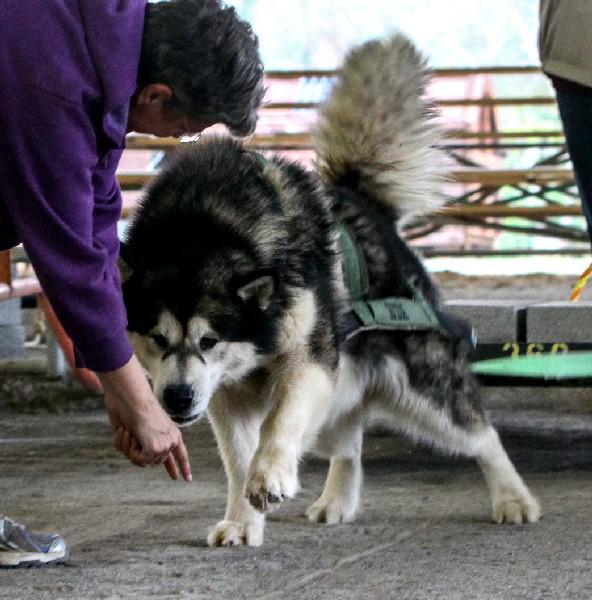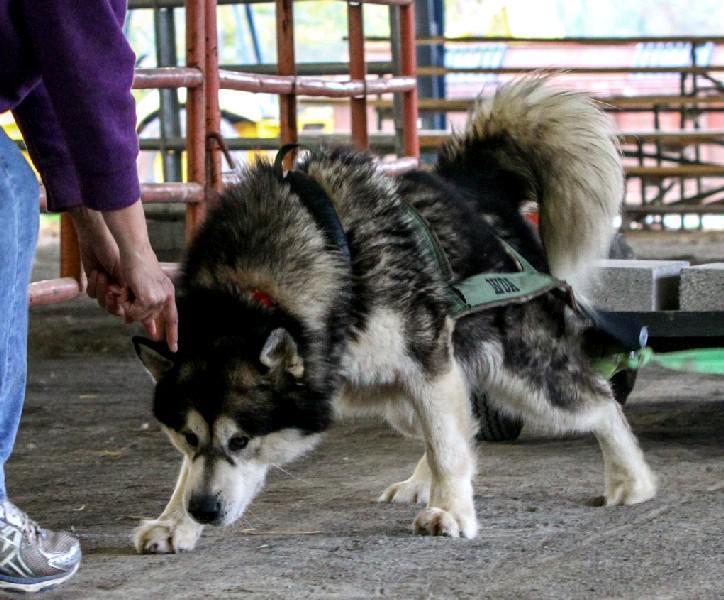The first image is the image on the left, the second image is the image on the right. Analyze the images presented: Is the assertion "At least one of the dogs is opening its mouth." valid? Answer yes or no. No. The first image is the image on the left, the second image is the image on the right. For the images shown, is this caption "At least one dog has blue eyes." true? Answer yes or no. No. 